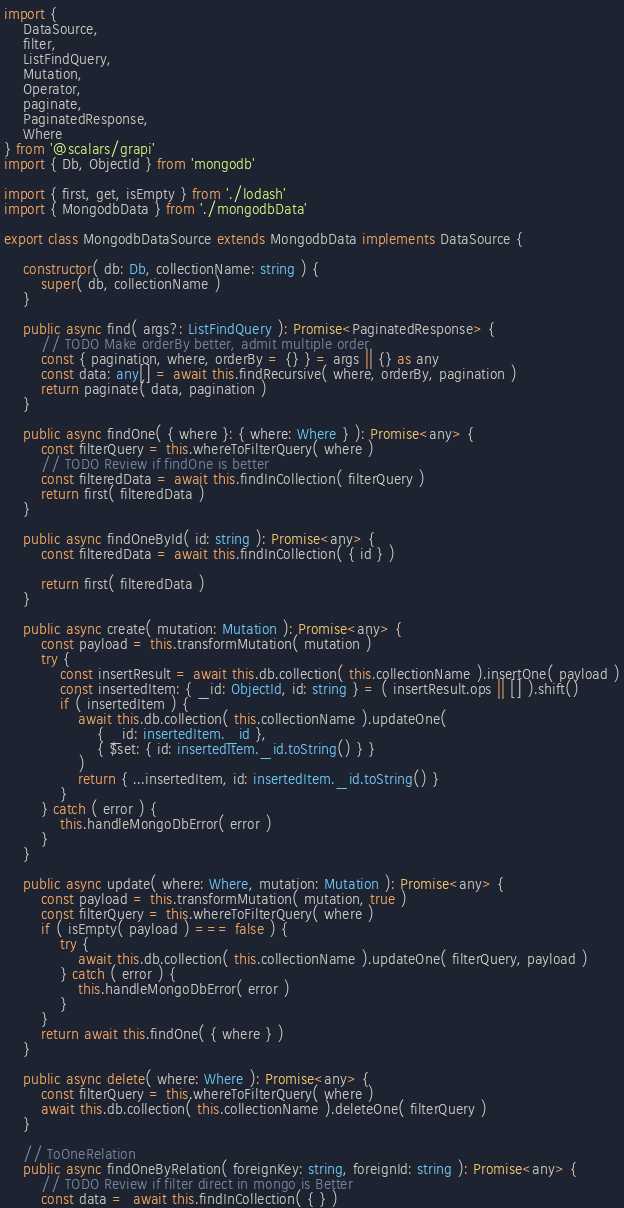Convert code to text. <code><loc_0><loc_0><loc_500><loc_500><_TypeScript_>import {
    DataSource,
    filter,
    ListFindQuery,
    Mutation,
    Operator,
    paginate,
    PaginatedResponse,
    Where
} from '@scalars/grapi'
import { Db, ObjectId } from 'mongodb'

import { first, get, isEmpty } from './lodash'
import { MongodbData } from './mongodbData'

export class MongodbDataSource extends MongodbData implements DataSource {

    constructor( db: Db, collectionName: string ) {
        super( db, collectionName )
    }

    public async find( args?: ListFindQuery ): Promise<PaginatedResponse> {
        // TODO Make orderBy better, admit multiple order
        const { pagination, where, orderBy = {} } = args || {} as any
        const data: any[] = await this.findRecursive( where, orderBy, pagination )
        return paginate( data, pagination )
    }

    public async findOne( { where }: { where: Where } ): Promise<any> {
        const filterQuery = this.whereToFilterQuery( where )
        // TODO Review if findOne is better
        const filteredData = await this.findInCollection( filterQuery )
        return first( filteredData )
    }

    public async findOneById( id: string ): Promise<any> {
        const filteredData = await this.findInCollection( { id } )

        return first( filteredData )
    }

    public async create( mutation: Mutation ): Promise<any> {
        const payload = this.transformMutation( mutation )
        try {
            const insertResult = await this.db.collection( this.collectionName ).insertOne( payload )
            const insertedItem: { _id: ObjectId, id: string } = ( insertResult.ops || [] ).shift()
            if ( insertedItem ) {
                await this.db.collection( this.collectionName ).updateOne(
                    { _id: insertedItem._id },
                    { $set: { id: insertedItem._id.toString() } }
                )
                return { ...insertedItem, id: insertedItem._id.toString() }
            }
        } catch ( error ) {
            this.handleMongoDbError( error )
        }
    }

    public async update( where: Where, mutation: Mutation ): Promise<any> {
        const payload = this.transformMutation( mutation, true )
        const filterQuery = this.whereToFilterQuery( where )
        if ( isEmpty( payload ) === false ) {
            try {
                await this.db.collection( this.collectionName ).updateOne( filterQuery, payload )
            } catch ( error ) {
                this.handleMongoDbError( error )
            }
        }
        return await this.findOne( { where } )
    }

    public async delete( where: Where ): Promise<any> {
        const filterQuery = this.whereToFilterQuery( where )
        await this.db.collection( this.collectionName ).deleteOne( filterQuery )
    }

    // ToOneRelation
    public async findOneByRelation( foreignKey: string, foreignId: string ): Promise<any> {
        // TODO Review if filter direct in mongo is Better
        const data =  await this.findInCollection( { } )</code> 